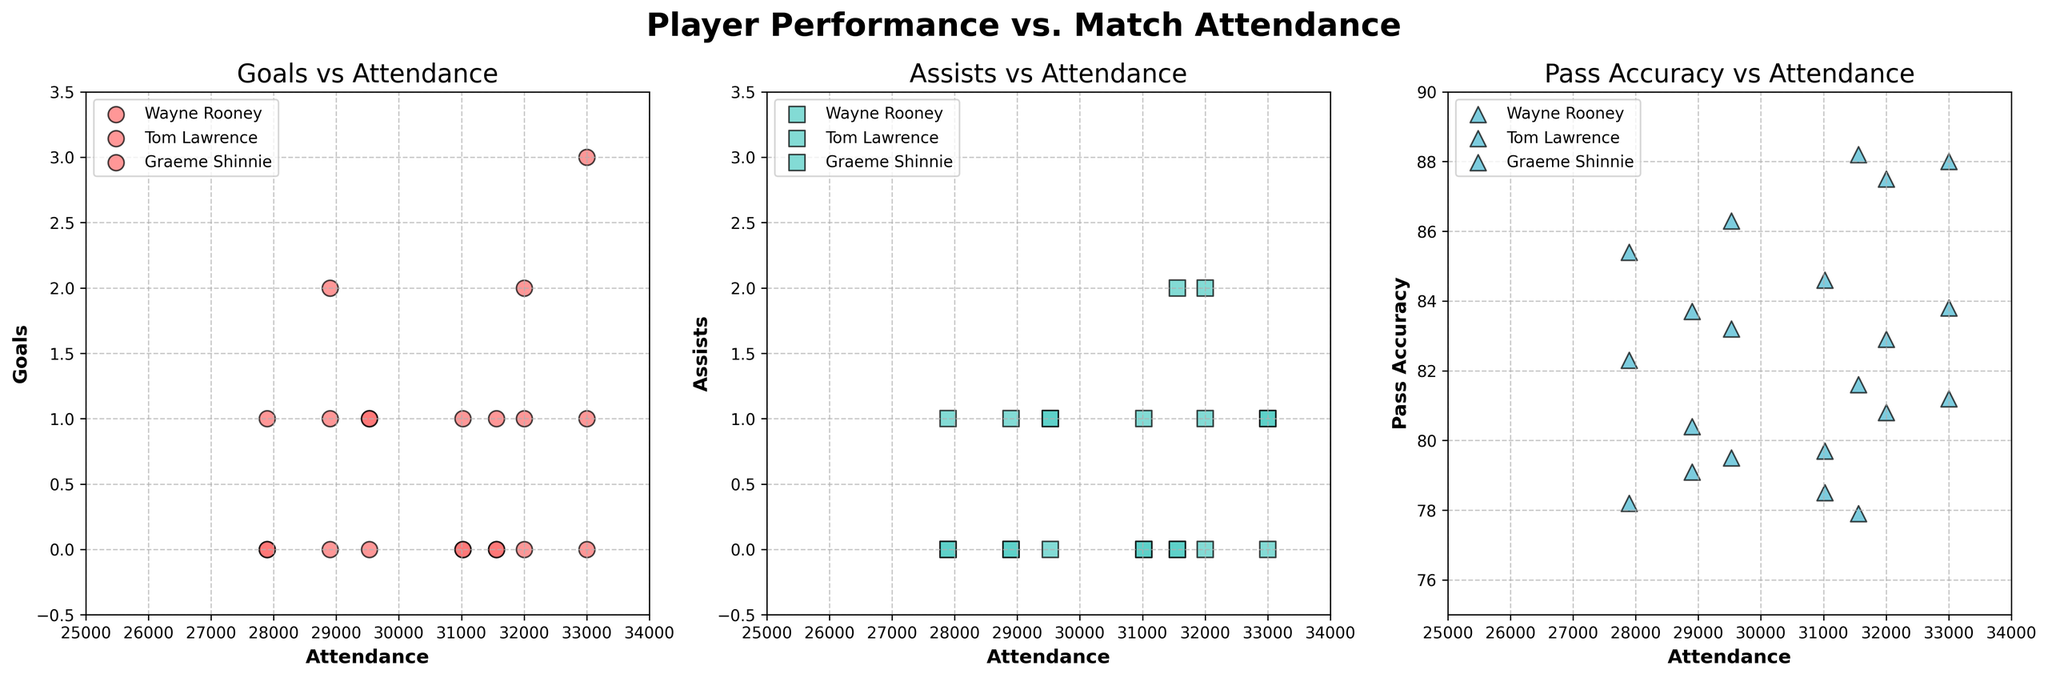What's the title of the figure? The title is usually located at the top of the figure. Here, it reads "Player Performance vs. Match Attendance".
Answer: Player Performance vs. Match Attendance Which metric is being compared to attendance in the first subplot? The first subplot is titled "Goals vs Attendance", indicating that the metric being compared with attendance is Goals.
Answer: Goals What is the color of the data points representing Goals in the first subplot? The color of the data points in the first subplot is a specific shade of red.
Answer: Red Which player has the highest number of goals in a single match according to the figure? By looking at the scatter plot for Goals vs Attendance, we see that Wayne Rooney has a data point at (33,000, 3), indicating 3 goals in a single match.
Answer: Wayne Rooney What is the pass accuracy range displayed on the y-axis in the third subplot? The y-axis of the Pass Accuracy subplot shows values ranging from 75 to 90.
Answer: 75 to 90 Comparing Wayne Rooney's performances, does higher attendance correlate with higher goal count? For Wayne Rooney, points with higher attendance (above 31,000) generally show higher goal counts, particularly the data points at 32,001 with 2 goals and 33,000 with 3 goals.
Answer: Yes How many assists did Tom Lawrence have in the match with an attendance of 31,560? By looking at the Assists vs Attendance subplot, Tom Lawrence had 2 assists in the match with an attendance of 31,560.
Answer: 2 Which player displays the most consistent pass accuracy across all matches? In the Pass Accuracy subplot, Wayne Rooney's dots appear at consistently high pass accuracy values compared to others.
Answer: Wayne Rooney Is there an observable pattern between attendance and assists for Graeme Shinnie? Graeme Shinnie’s assists do not show a clear pattern with attendance; his assists are mostly clustered around zero across different attendance levels.
Answer: No clear pattern What is the range of attendance values displayed on the x-axes of the subplots? The x-axes of the subplots show attendance values ranging from 25,000 to 34,000.
Answer: 25,000 to 34,000 